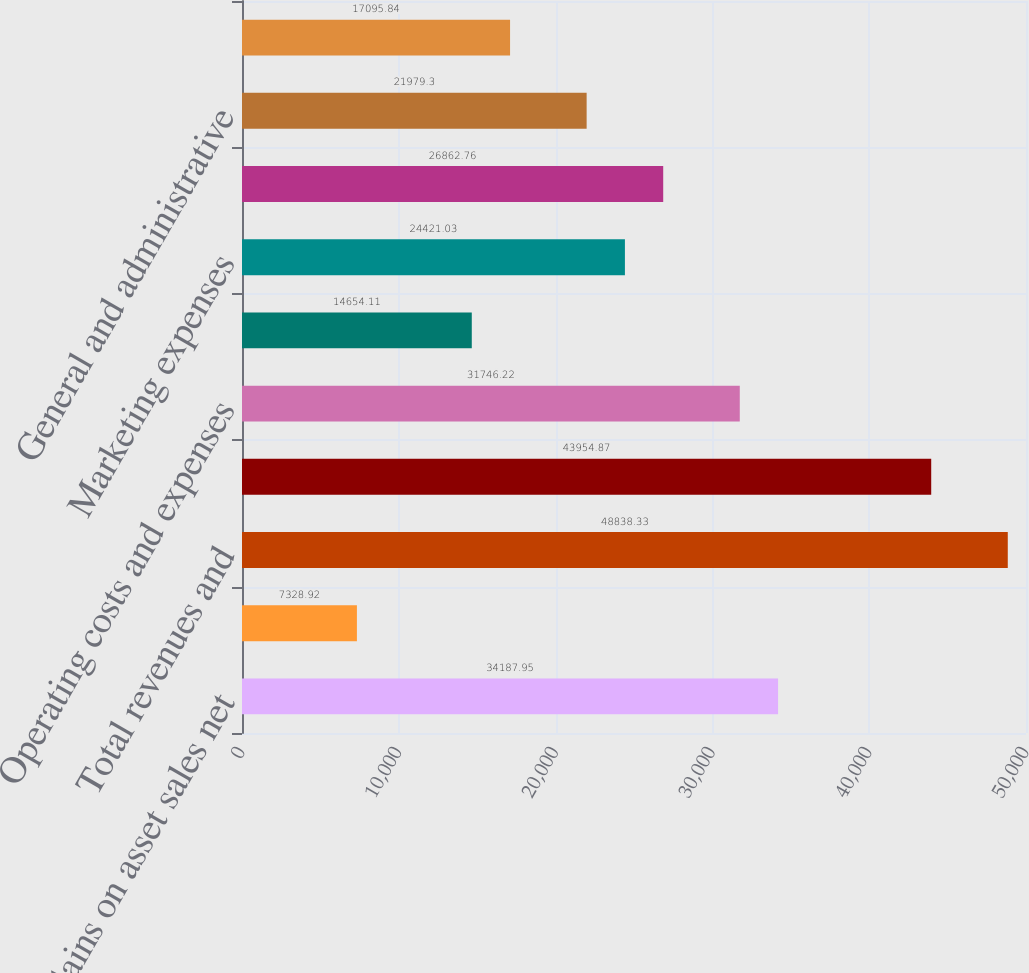Convert chart. <chart><loc_0><loc_0><loc_500><loc_500><bar_chart><fcel>Gains on asset sales net<fcel>Other net<fcel>Total revenues and<fcel>Cost of products sold<fcel>Operating costs and expenses<fcel>Production and severance taxes<fcel>Marketing expenses<fcel>Exploration expenses including<fcel>General and administrative<fcel>Interest expense<nl><fcel>34187.9<fcel>7328.92<fcel>48838.3<fcel>43954.9<fcel>31746.2<fcel>14654.1<fcel>24421<fcel>26862.8<fcel>21979.3<fcel>17095.8<nl></chart> 